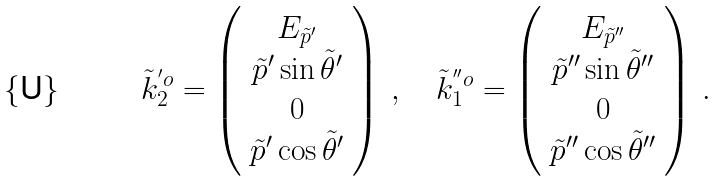Convert formula to latex. <formula><loc_0><loc_0><loc_500><loc_500>\tilde { k } ^ { ^ { \prime } o } _ { 2 } = \left ( \begin{array} { c } E _ { \tilde { p } ^ { \prime } } \\ \tilde { p } ^ { \prime } \sin \tilde { \theta } ^ { \prime } \\ 0 \\ \tilde { p } ^ { \prime } \cos \tilde { \theta } ^ { \prime } \end{array} \right ) \, , \quad \tilde { k } ^ { ^ { \prime \prime } o } _ { 1 } = \left ( \begin{array} { c } E _ { \tilde { p } ^ { \prime \prime } } \\ \tilde { p } ^ { \prime \prime } \sin \tilde { \theta } ^ { \prime \prime } \\ 0 \\ \tilde { p } ^ { \prime \prime } \cos \tilde { \theta } ^ { \prime \prime } \end{array} \right ) \, .</formula> 